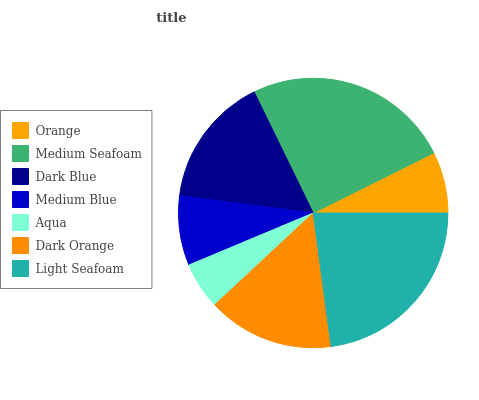Is Aqua the minimum?
Answer yes or no. Yes. Is Medium Seafoam the maximum?
Answer yes or no. Yes. Is Dark Blue the minimum?
Answer yes or no. No. Is Dark Blue the maximum?
Answer yes or no. No. Is Medium Seafoam greater than Dark Blue?
Answer yes or no. Yes. Is Dark Blue less than Medium Seafoam?
Answer yes or no. Yes. Is Dark Blue greater than Medium Seafoam?
Answer yes or no. No. Is Medium Seafoam less than Dark Blue?
Answer yes or no. No. Is Dark Orange the high median?
Answer yes or no. Yes. Is Dark Orange the low median?
Answer yes or no. Yes. Is Orange the high median?
Answer yes or no. No. Is Medium Blue the low median?
Answer yes or no. No. 